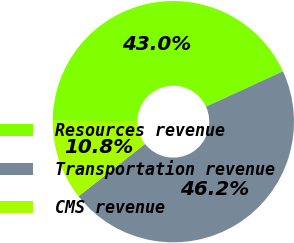<chart> <loc_0><loc_0><loc_500><loc_500><pie_chart><fcel>Resources revenue<fcel>Transportation revenue<fcel>CMS revenue<nl><fcel>43.01%<fcel>46.24%<fcel>10.75%<nl></chart> 